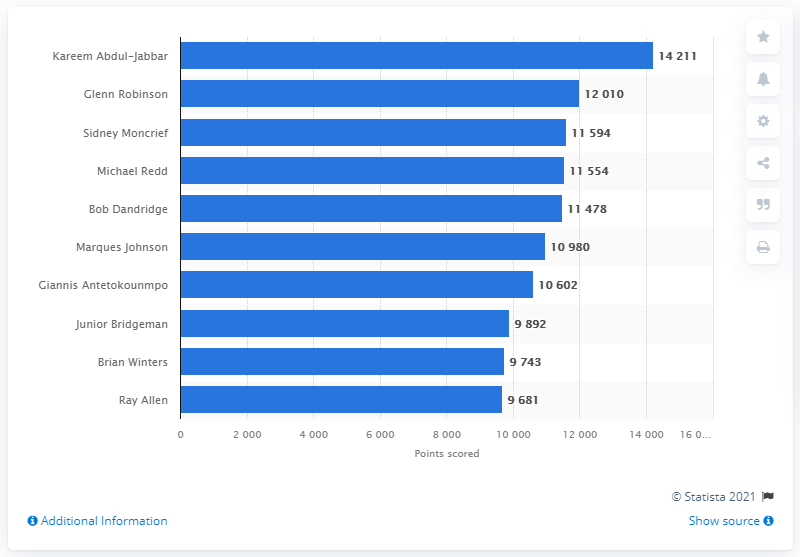Point out several critical features in this image. Kareem Abdul-Jabbar is the career points leader of the Milwaukee Bucks. 